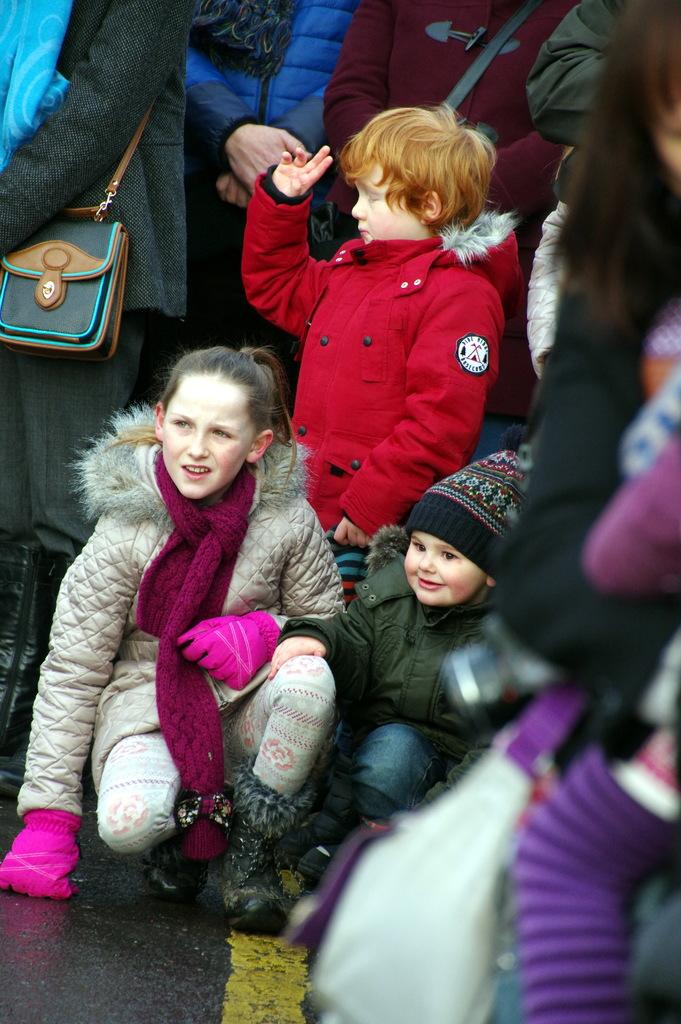Who is present in the image? There are people and children in the image. What are the people and children doing in the image? They are sitting and standing on the road. Can you describe any accessories that some people are wearing? Some people are wearing handbags. What type of heart-shaped object can be seen in the image? There is no heart-shaped object present in the image. Is there a veil visible on any of the children in the image? There is no veil visible on any of the children in the image. 